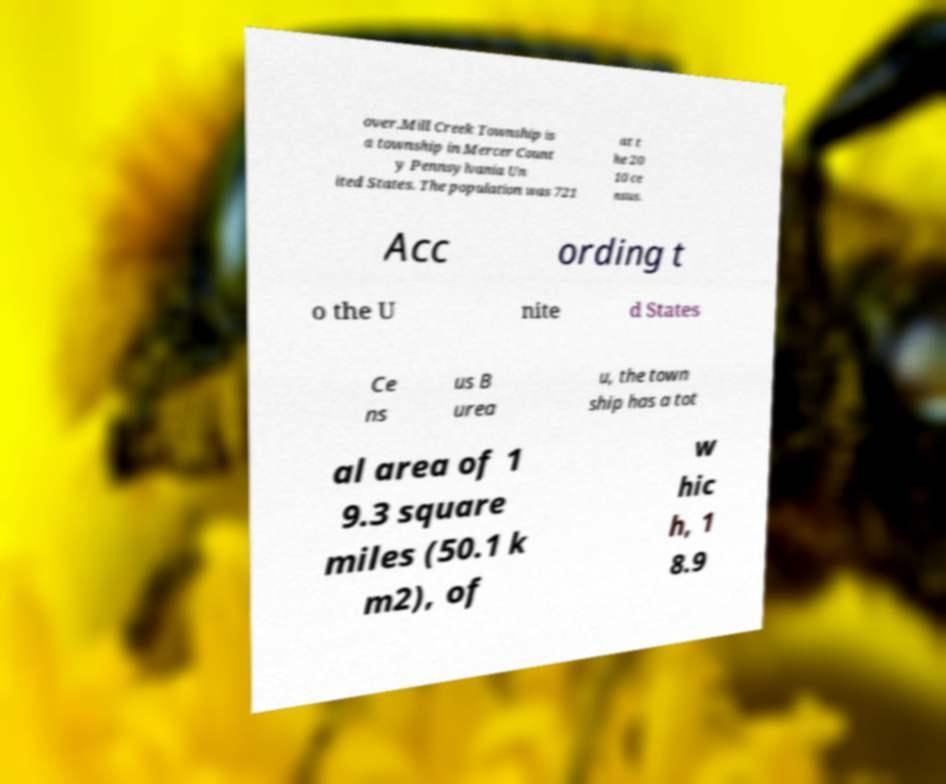Can you read and provide the text displayed in the image?This photo seems to have some interesting text. Can you extract and type it out for me? over.Mill Creek Township is a township in Mercer Count y Pennsylvania Un ited States. The population was 721 at t he 20 10 ce nsus. Acc ording t o the U nite d States Ce ns us B urea u, the town ship has a tot al area of 1 9.3 square miles (50.1 k m2), of w hic h, 1 8.9 